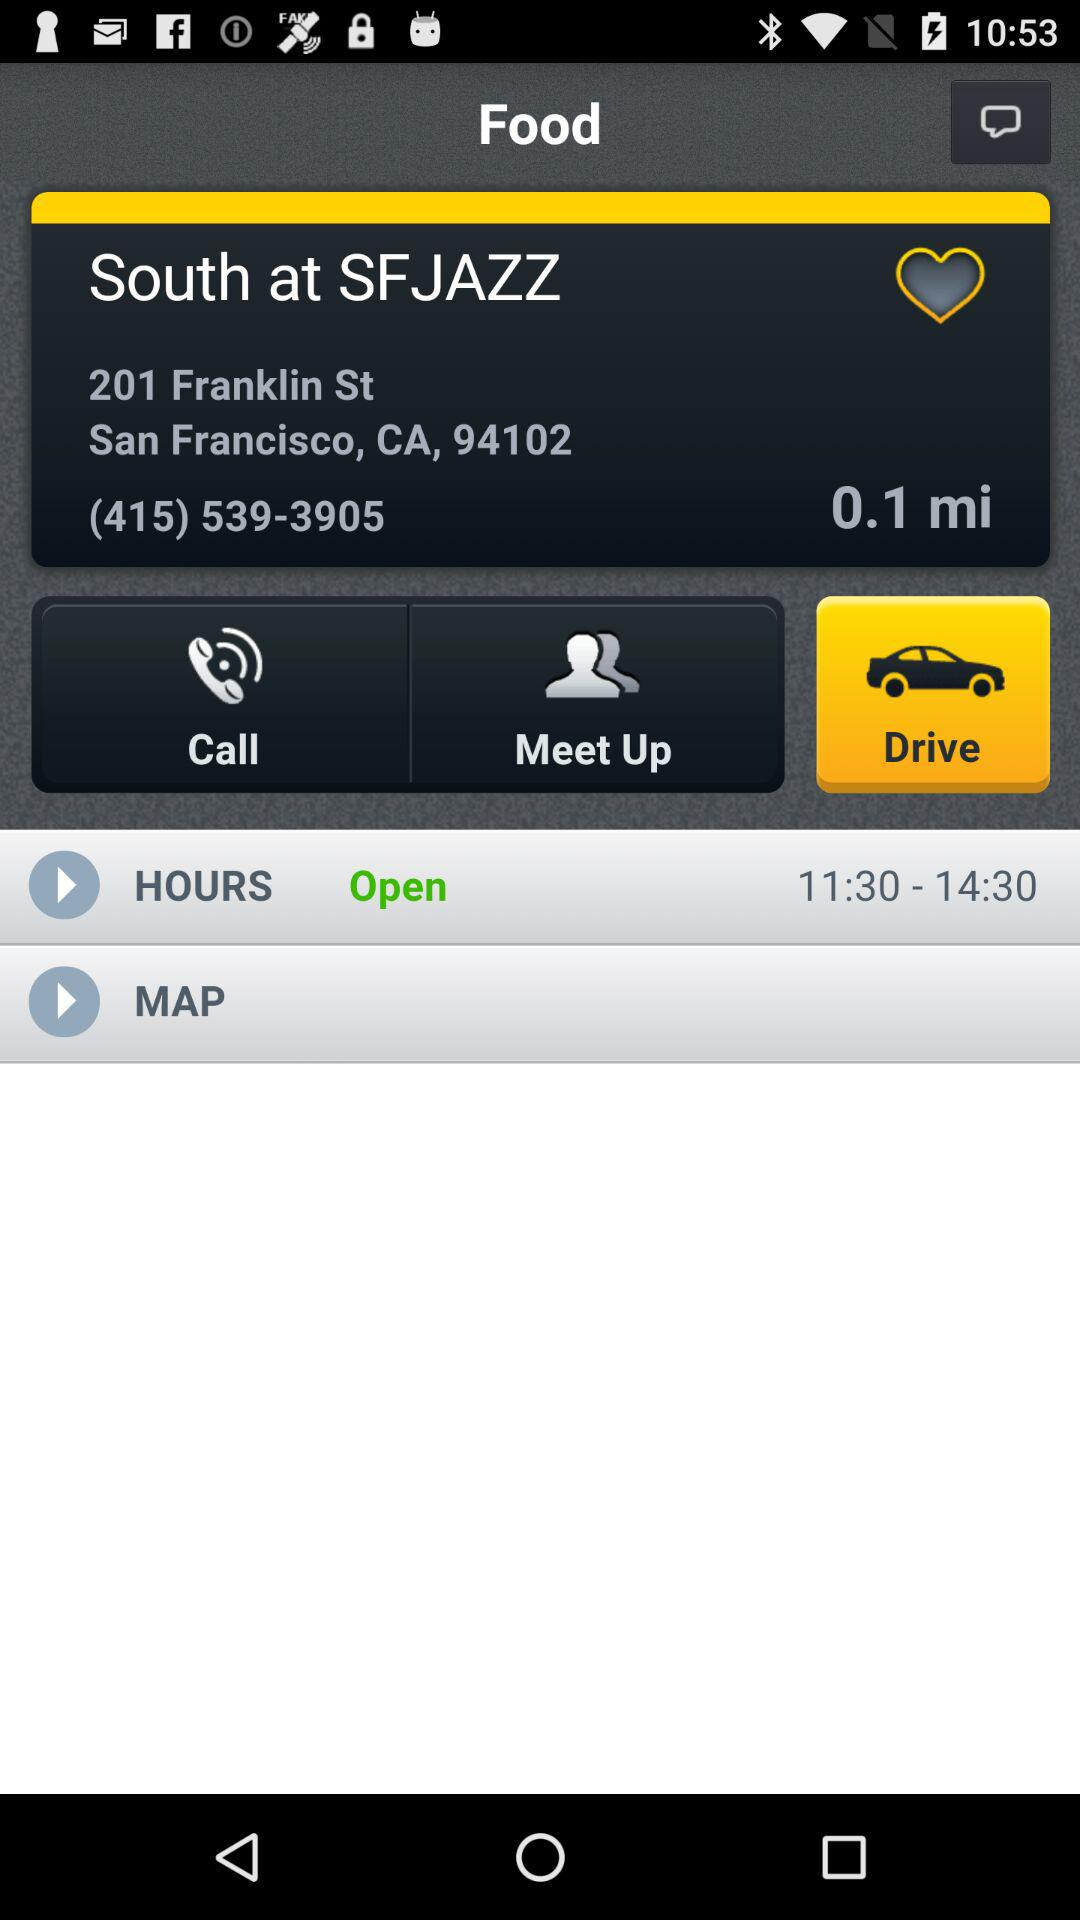What is the phone number given? The phone number given is (415) 539-3905. 